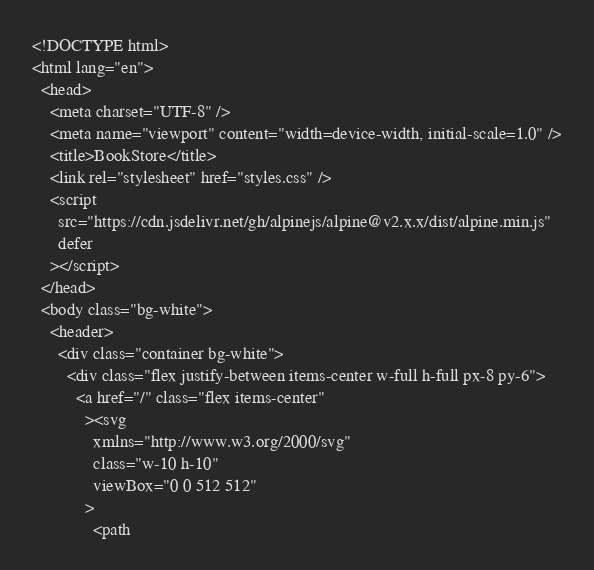<code> <loc_0><loc_0><loc_500><loc_500><_PHP_><!DOCTYPE html>
<html lang="en">
  <head>
    <meta charset="UTF-8" />
    <meta name="viewport" content="width=device-width, initial-scale=1.0" />
    <title>BookStore</title>
    <link rel="stylesheet" href="styles.css" />
    <script
      src="https://cdn.jsdelivr.net/gh/alpinejs/alpine@v2.x.x/dist/alpine.min.js"
      defer
    ></script>
  </head>
  <body class="bg-white">
    <header>
      <div class="container bg-white">
        <div class="flex justify-between items-center w-full h-full px-8 py-6">
          <a href="/" class="flex items-center"
            ><svg
              xmlns="http://www.w3.org/2000/svg"
              class="w-10 h-10"
              viewBox="0 0 512 512"
            >
              <path</code> 